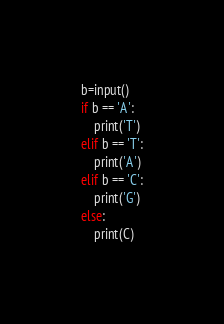Convert code to text. <code><loc_0><loc_0><loc_500><loc_500><_Python_>b=input()
if b == 'A':
    print('T')
elif b == 'T':
    print('A')
elif b == 'C':
    print('G')
else:
    print(C)</code> 